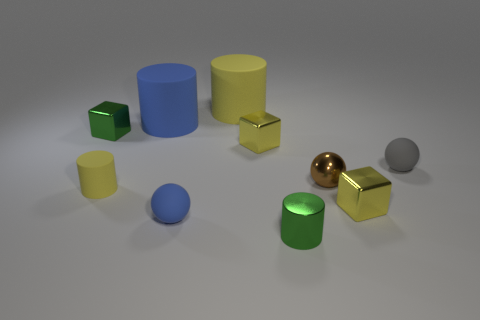What number of tiny rubber balls have the same color as the metallic cylinder? In the image, there are no tiny rubber balls that share the same color as the metallic cylinder; the cylinder is gold, and none of the rubber balls match that color. 